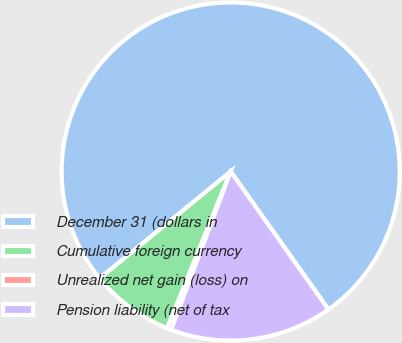Convert chart to OTSL. <chart><loc_0><loc_0><loc_500><loc_500><pie_chart><fcel>December 31 (dollars in<fcel>Cumulative foreign currency<fcel>Unrealized net gain (loss) on<fcel>Pension liability (net of tax<nl><fcel>76.08%<fcel>7.97%<fcel>0.41%<fcel>15.54%<nl></chart> 